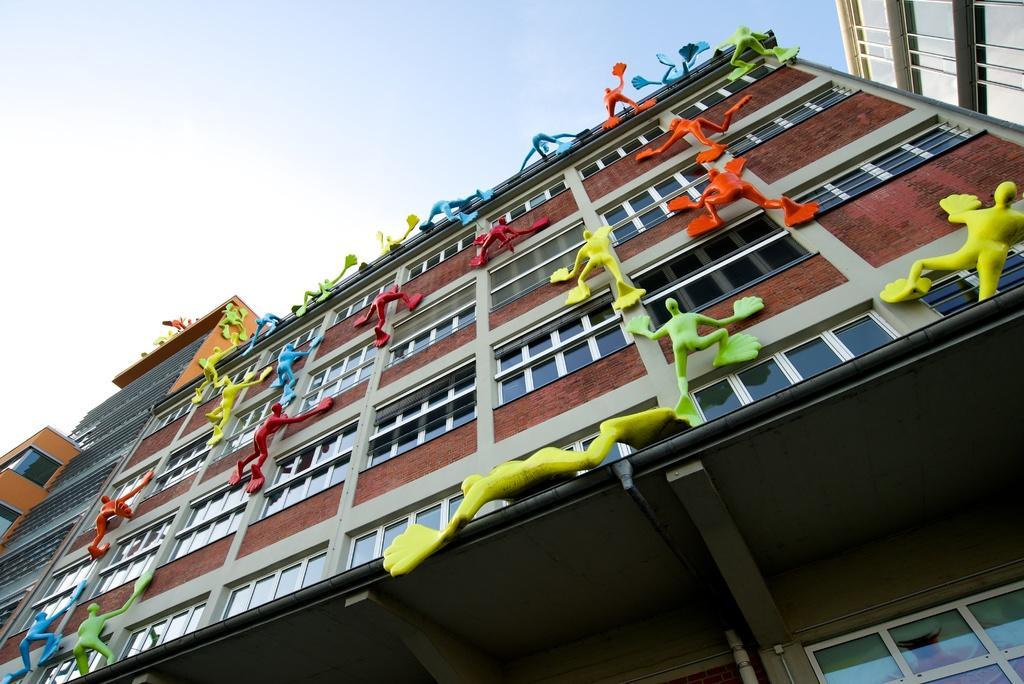Describe this image in one or two sentences. These are the buildings with the windows. I can see the kind of colorful sculptures, which are on the building. This is the sky. 